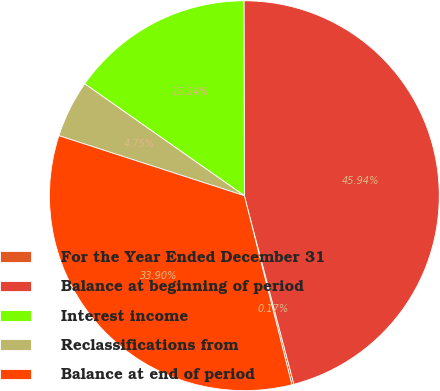Convert chart to OTSL. <chart><loc_0><loc_0><loc_500><loc_500><pie_chart><fcel>For the Year Ended December 31<fcel>Balance at beginning of period<fcel>Interest income<fcel>Reclassifications from<fcel>Balance at end of period<nl><fcel>0.17%<fcel>45.94%<fcel>15.24%<fcel>4.75%<fcel>33.9%<nl></chart> 